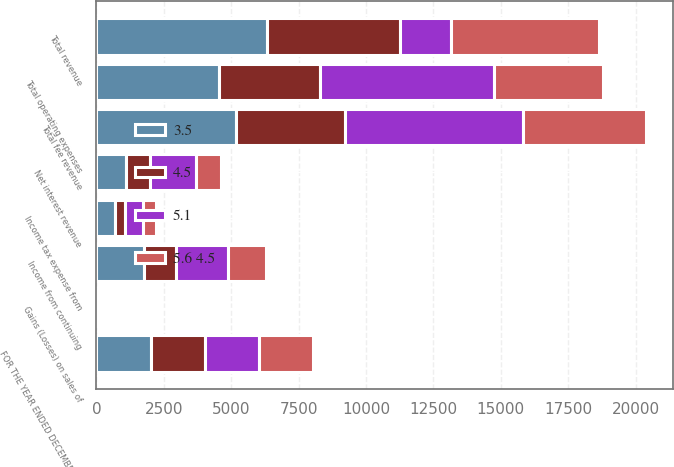Convert chart to OTSL. <chart><loc_0><loc_0><loc_500><loc_500><stacked_bar_chart><ecel><fcel>FOR THE YEAR ENDED DECEMBER 31<fcel>Total fee revenue<fcel>Net interest revenue<fcel>Gains (Losses) on sales of<fcel>Total revenue<fcel>Total operating expenses<fcel>Income from continuing<fcel>Income tax expense from<nl><fcel>5.1<fcel>2007<fcel>6599<fcel>1730<fcel>7<fcel>1903<fcel>6433<fcel>1903<fcel>642<nl><fcel>3.5<fcel>2006<fcel>5186<fcel>1110<fcel>15<fcel>6311<fcel>4540<fcel>1771<fcel>675<nl><fcel>5.6 4.5<fcel>2005<fcel>4551<fcel>907<fcel>1<fcel>5473<fcel>4041<fcel>1432<fcel>487<nl><fcel>4.5<fcel>2004<fcel>4048<fcel>859<fcel>26<fcel>4951<fcel>3759<fcel>1192<fcel>394<nl></chart> 